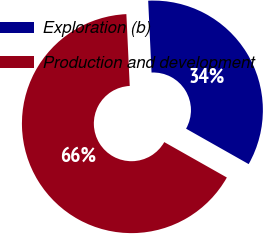<chart> <loc_0><loc_0><loc_500><loc_500><pie_chart><fcel>Exploration (b)<fcel>Production and development<nl><fcel>33.94%<fcel>66.06%<nl></chart> 